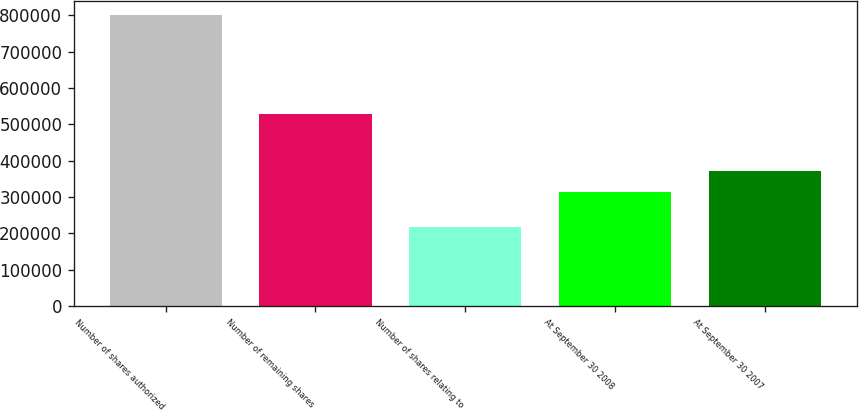Convert chart to OTSL. <chart><loc_0><loc_0><loc_500><loc_500><bar_chart><fcel>Number of shares authorized<fcel>Number of remaining shares<fcel>Number of shares relating to<fcel>At September 30 2008<fcel>At September 30 2007<nl><fcel>800000<fcel>530000<fcel>216500<fcel>313500<fcel>371850<nl></chart> 